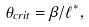<formula> <loc_0><loc_0><loc_500><loc_500>\theta _ { c r i t } = \beta / \ell ^ { * } ,</formula> 